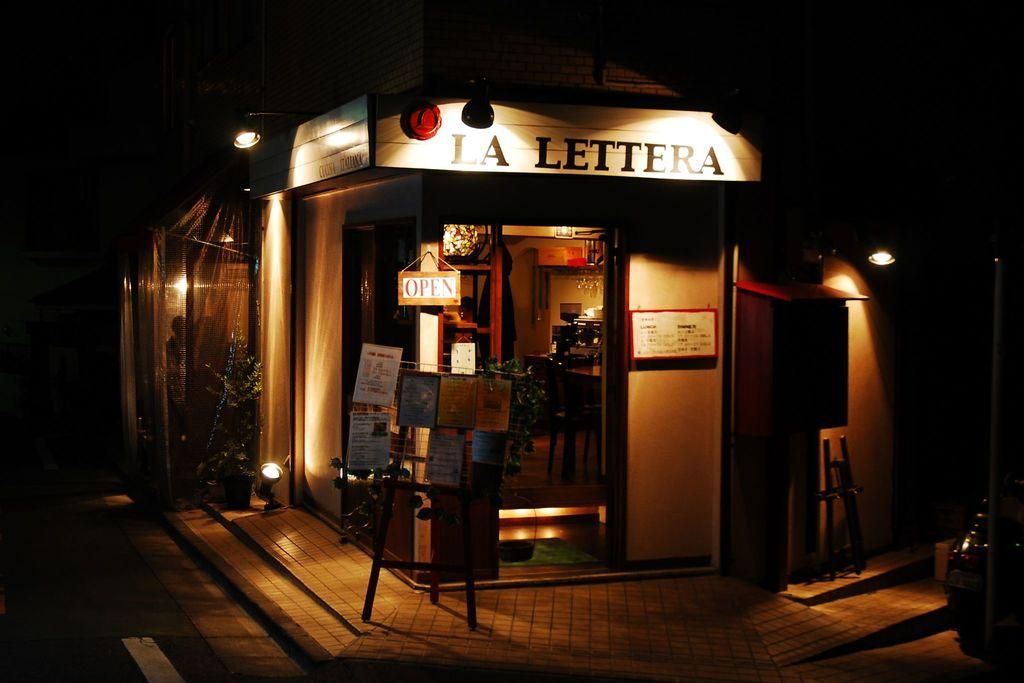<image>
Describe the image concisely. Lights show a sign for La Lettera and highlight a sign showing that it is open. 